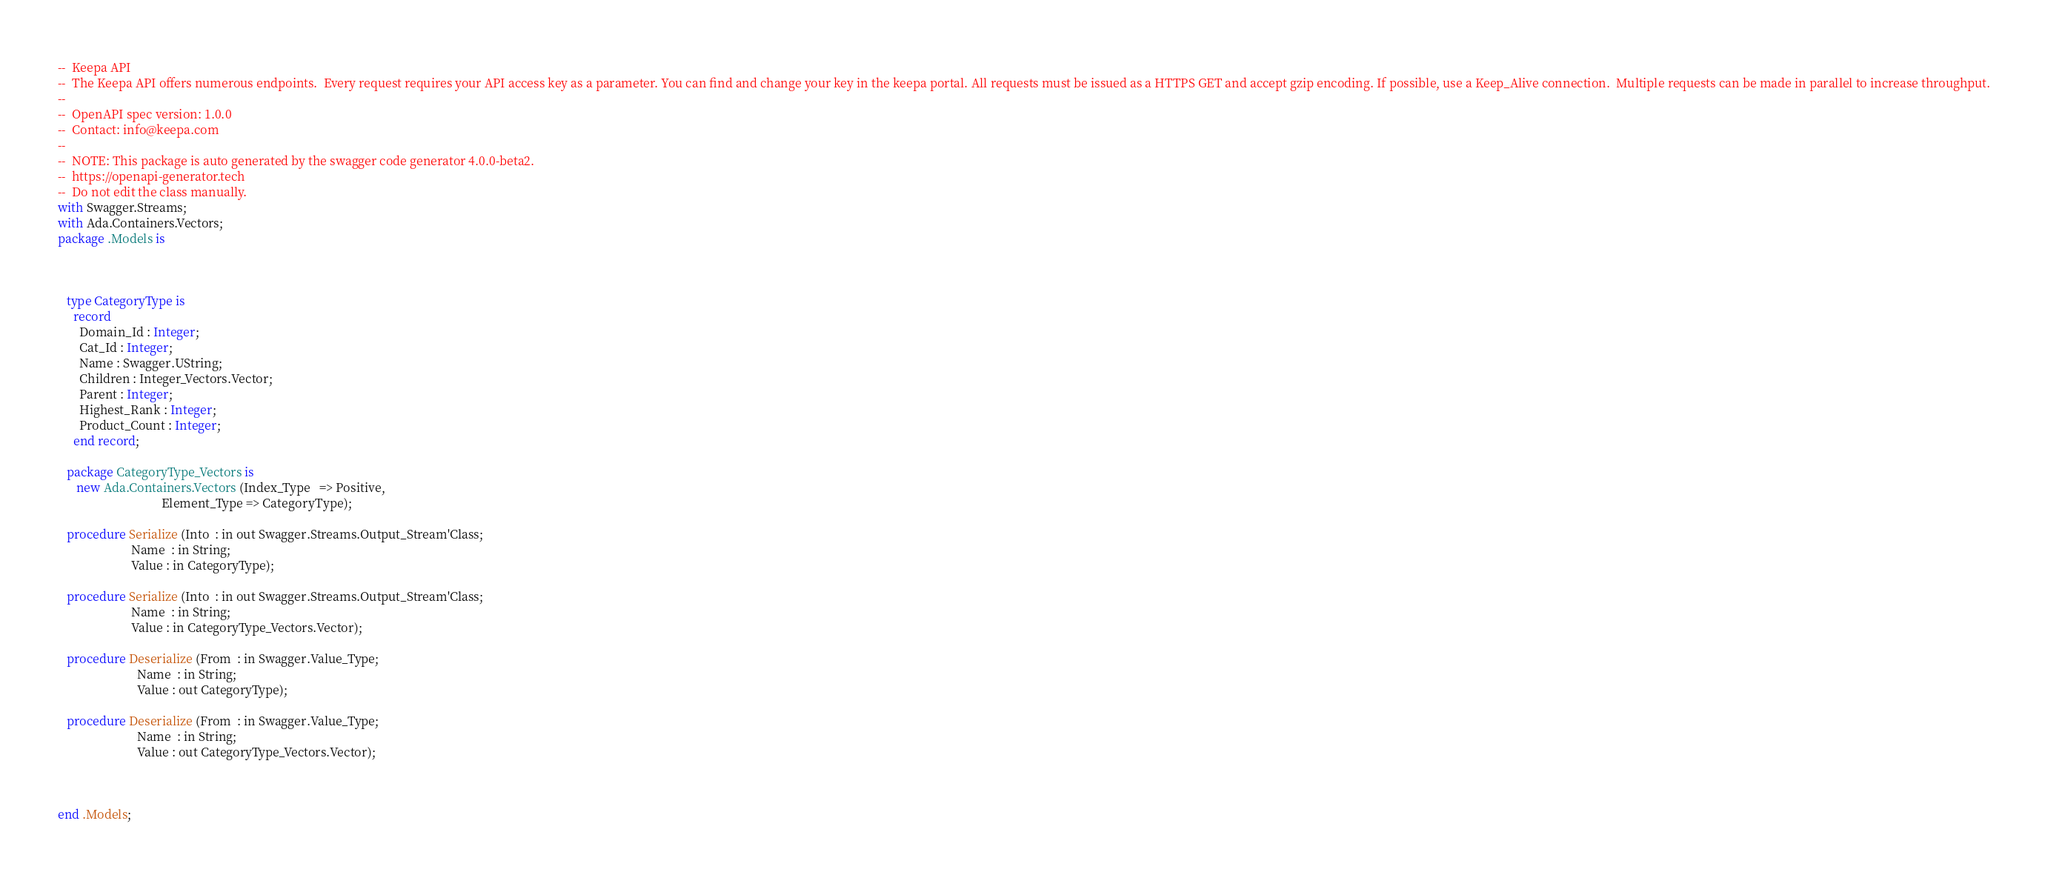<code> <loc_0><loc_0><loc_500><loc_500><_Ada_>--  Keepa API
--  The Keepa API offers numerous endpoints.  Every request requires your API access key as a parameter. You can find and change your key in the keepa portal. All requests must be issued as a HTTPS GET and accept gzip encoding. If possible, use a Keep_Alive connection.  Multiple requests can be made in parallel to increase throughput.
--
--  OpenAPI spec version: 1.0.0
--  Contact: info@keepa.com
--
--  NOTE: This package is auto generated by the swagger code generator 4.0.0-beta2.
--  https://openapi-generator.tech
--  Do not edit the class manually.
with Swagger.Streams;
with Ada.Containers.Vectors;
package .Models is



   type CategoryType is
     record
       Domain_Id : Integer;
       Cat_Id : Integer;
       Name : Swagger.UString;
       Children : Integer_Vectors.Vector;
       Parent : Integer;
       Highest_Rank : Integer;
       Product_Count : Integer;
     end record;

   package CategoryType_Vectors is
      new Ada.Containers.Vectors (Index_Type   => Positive,
                                  Element_Type => CategoryType);

   procedure Serialize (Into  : in out Swagger.Streams.Output_Stream'Class;
                        Name  : in String;
                        Value : in CategoryType);

   procedure Serialize (Into  : in out Swagger.Streams.Output_Stream'Class;
                        Name  : in String;
                        Value : in CategoryType_Vectors.Vector);

   procedure Deserialize (From  : in Swagger.Value_Type;
                          Name  : in String;
                          Value : out CategoryType);

   procedure Deserialize (From  : in Swagger.Value_Type;
                          Name  : in String;
                          Value : out CategoryType_Vectors.Vector);



end .Models;
</code> 